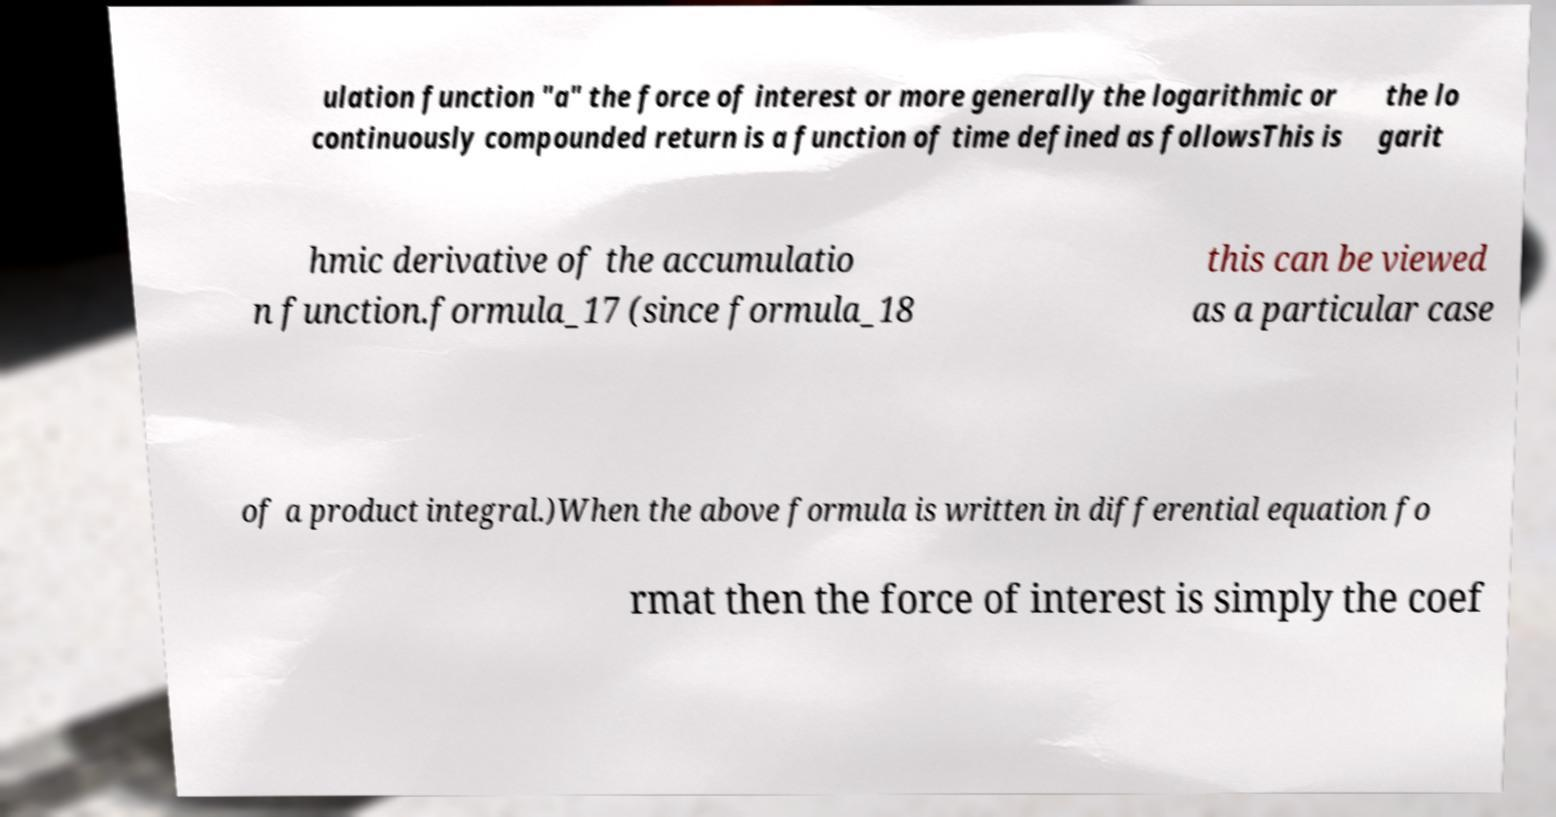I need the written content from this picture converted into text. Can you do that? ulation function "a" the force of interest or more generally the logarithmic or continuously compounded return is a function of time defined as followsThis is the lo garit hmic derivative of the accumulatio n function.formula_17 (since formula_18 this can be viewed as a particular case of a product integral.)When the above formula is written in differential equation fo rmat then the force of interest is simply the coef 